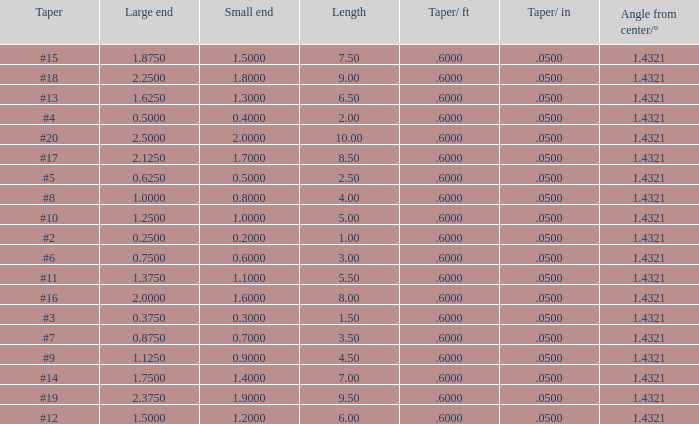Which Taper/in that has a Small end larger than 0.7000000000000001, and a Taper of #19, and a Large end larger than 2.375? None. 